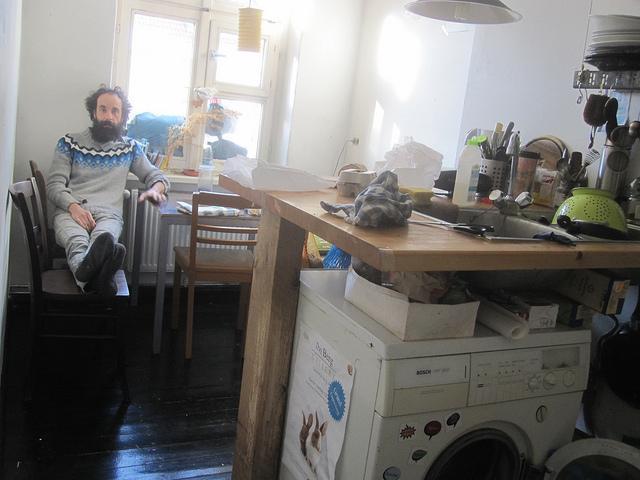How many chairs is this man sitting on?
Give a very brief answer. 2. How many chairs are there?
Give a very brief answer. 2. How many white airplanes do you see?
Give a very brief answer. 0. 